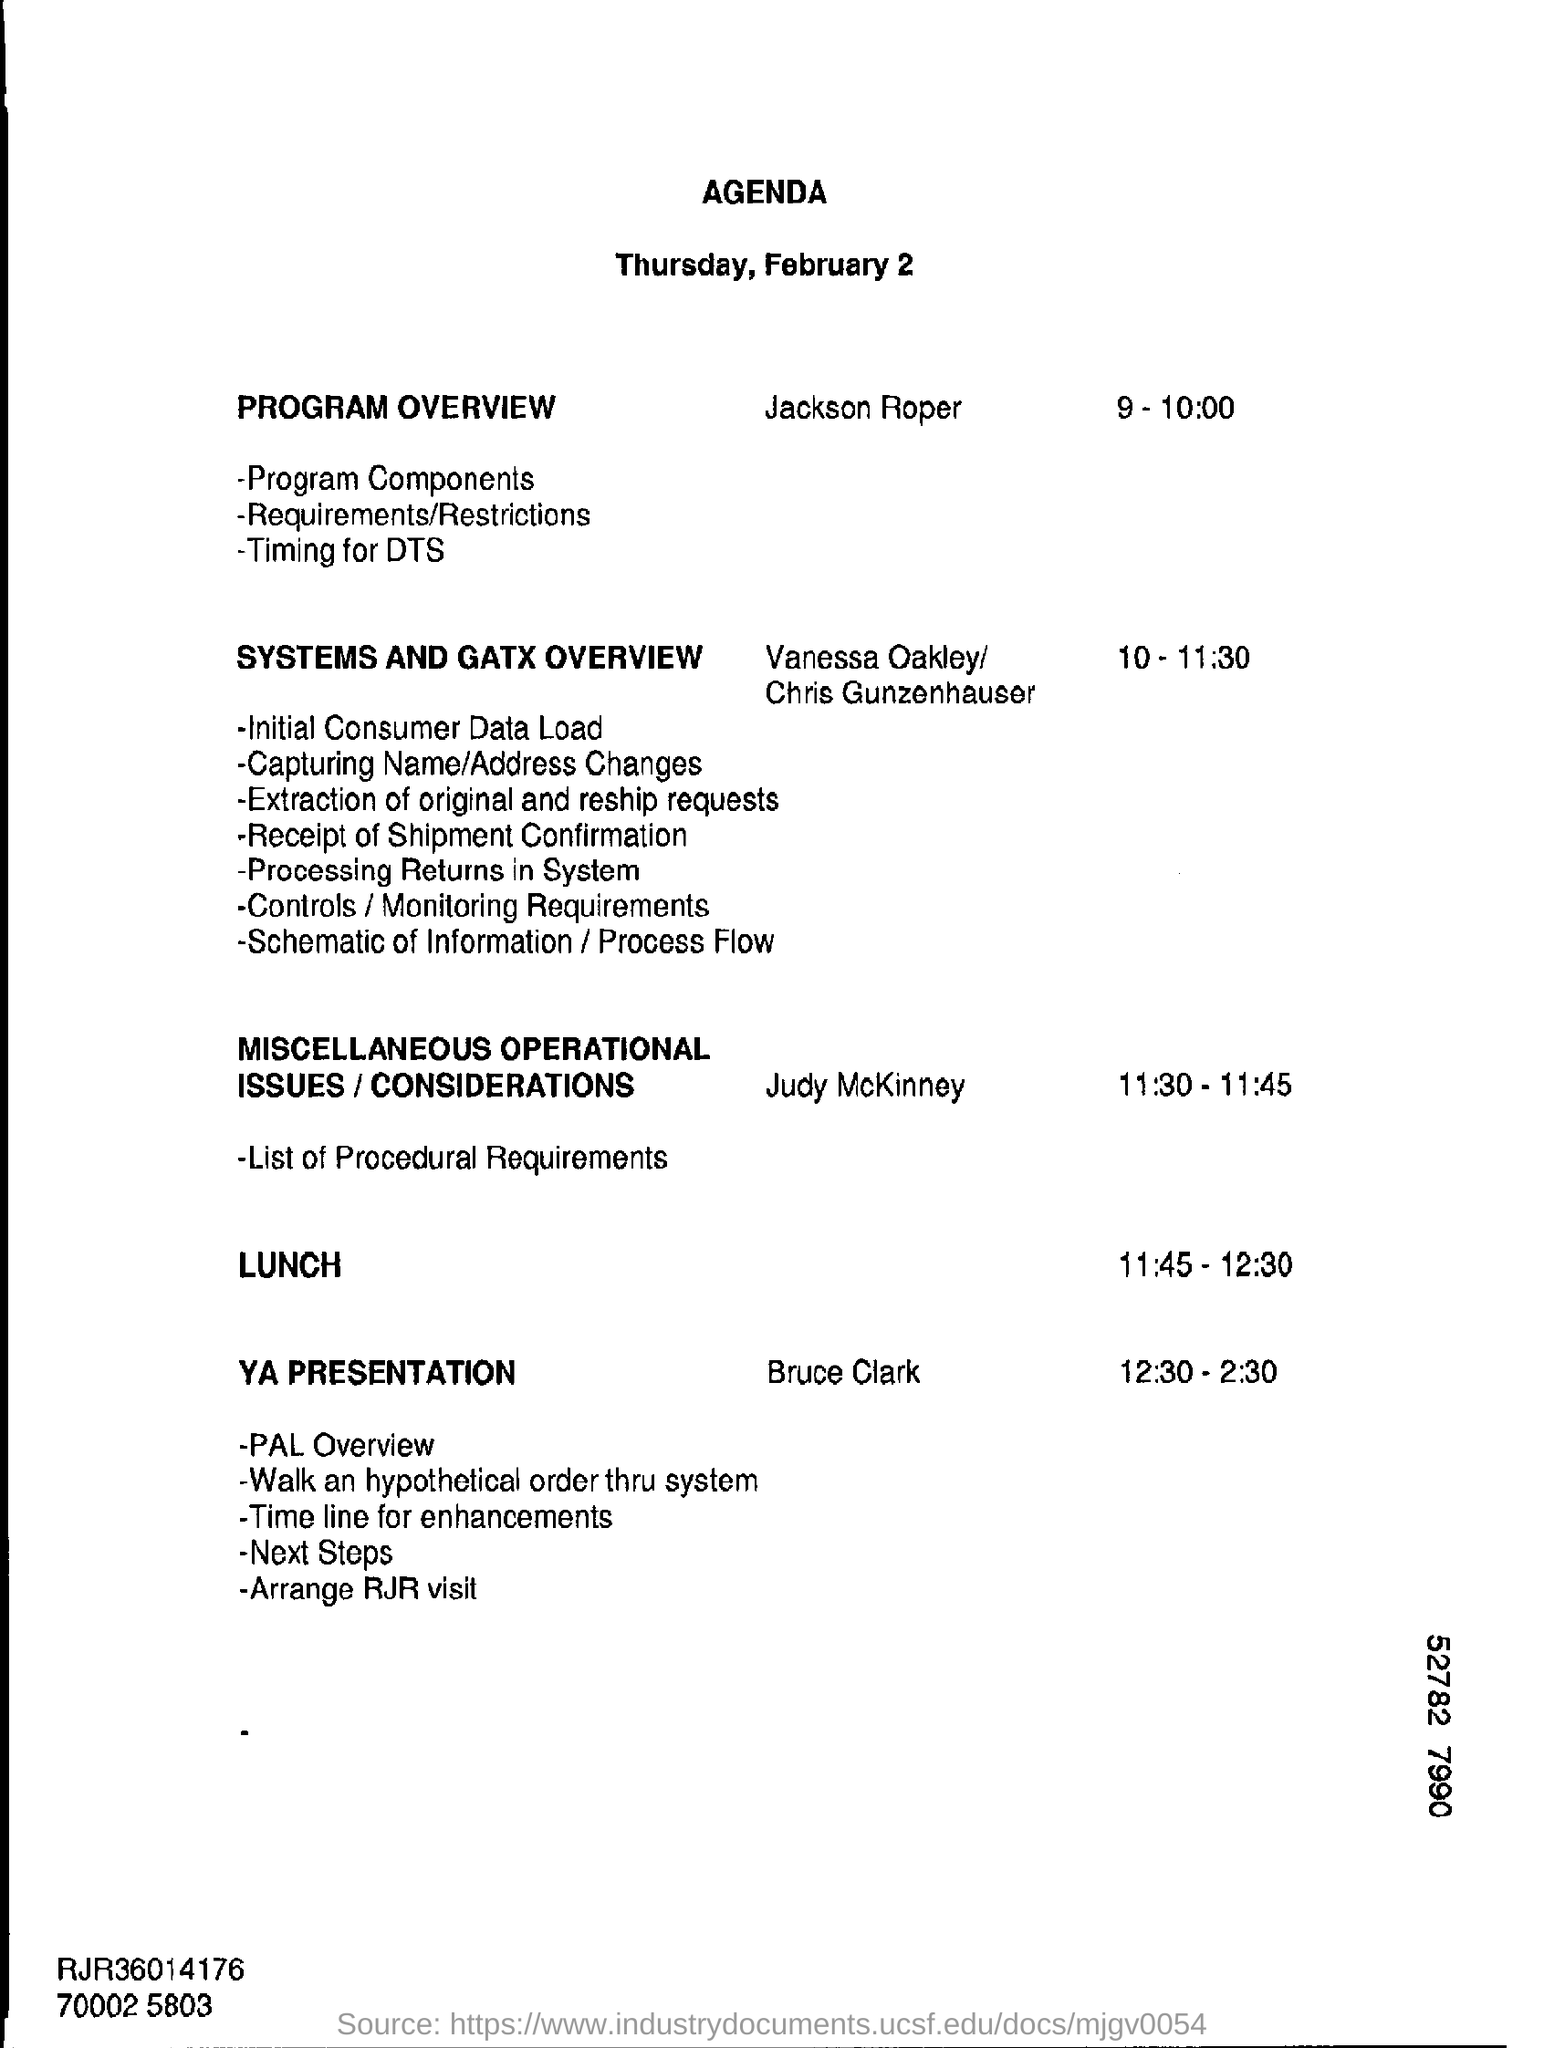What is digit shown at the bottom right corner?
Your response must be concise. 52782 7990. 